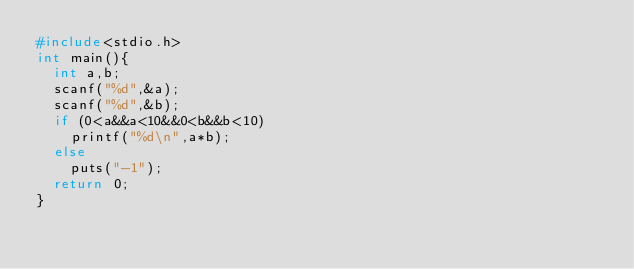Convert code to text. <code><loc_0><loc_0><loc_500><loc_500><_C_>#include<stdio.h>
int main(){
	int a,b;
	scanf("%d",&a);
	scanf("%d",&b);
	if (0<a&&a<10&&0<b&&b<10)
		printf("%d\n",a*b);
	else
		puts("-1");
	return 0;
}</code> 